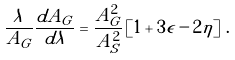Convert formula to latex. <formula><loc_0><loc_0><loc_500><loc_500>\frac { \lambda } { A _ { G } } \frac { d A _ { G } } { d \lambda } = \frac { A _ { G } ^ { 2 } } { A _ { S } ^ { 2 } } \left [ 1 + 3 \epsilon - 2 \eta \right ] \, .</formula> 